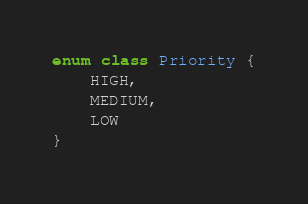Convert code to text. <code><loc_0><loc_0><loc_500><loc_500><_Kotlin_>enum class Priority {
    HIGH,
    MEDIUM,
    LOW
}
</code> 